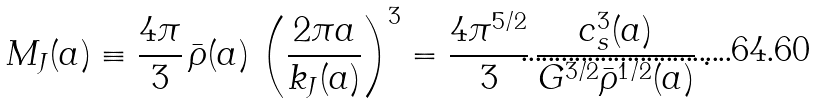Convert formula to latex. <formula><loc_0><loc_0><loc_500><loc_500>M _ { J } ( a ) \equiv \frac { 4 \pi } { 3 } \, \bar { \rho } ( a ) \, \left ( \frac { 2 \pi a } { k _ { J } ( a ) } \right ) ^ { 3 } = \frac { 4 \pi ^ { 5 / 2 } } { 3 } \, \frac { c _ { s } ^ { 3 } ( a ) } { G ^ { 3 / 2 } \bar { \rho } ^ { 1 / 2 } ( a ) } \, .</formula> 